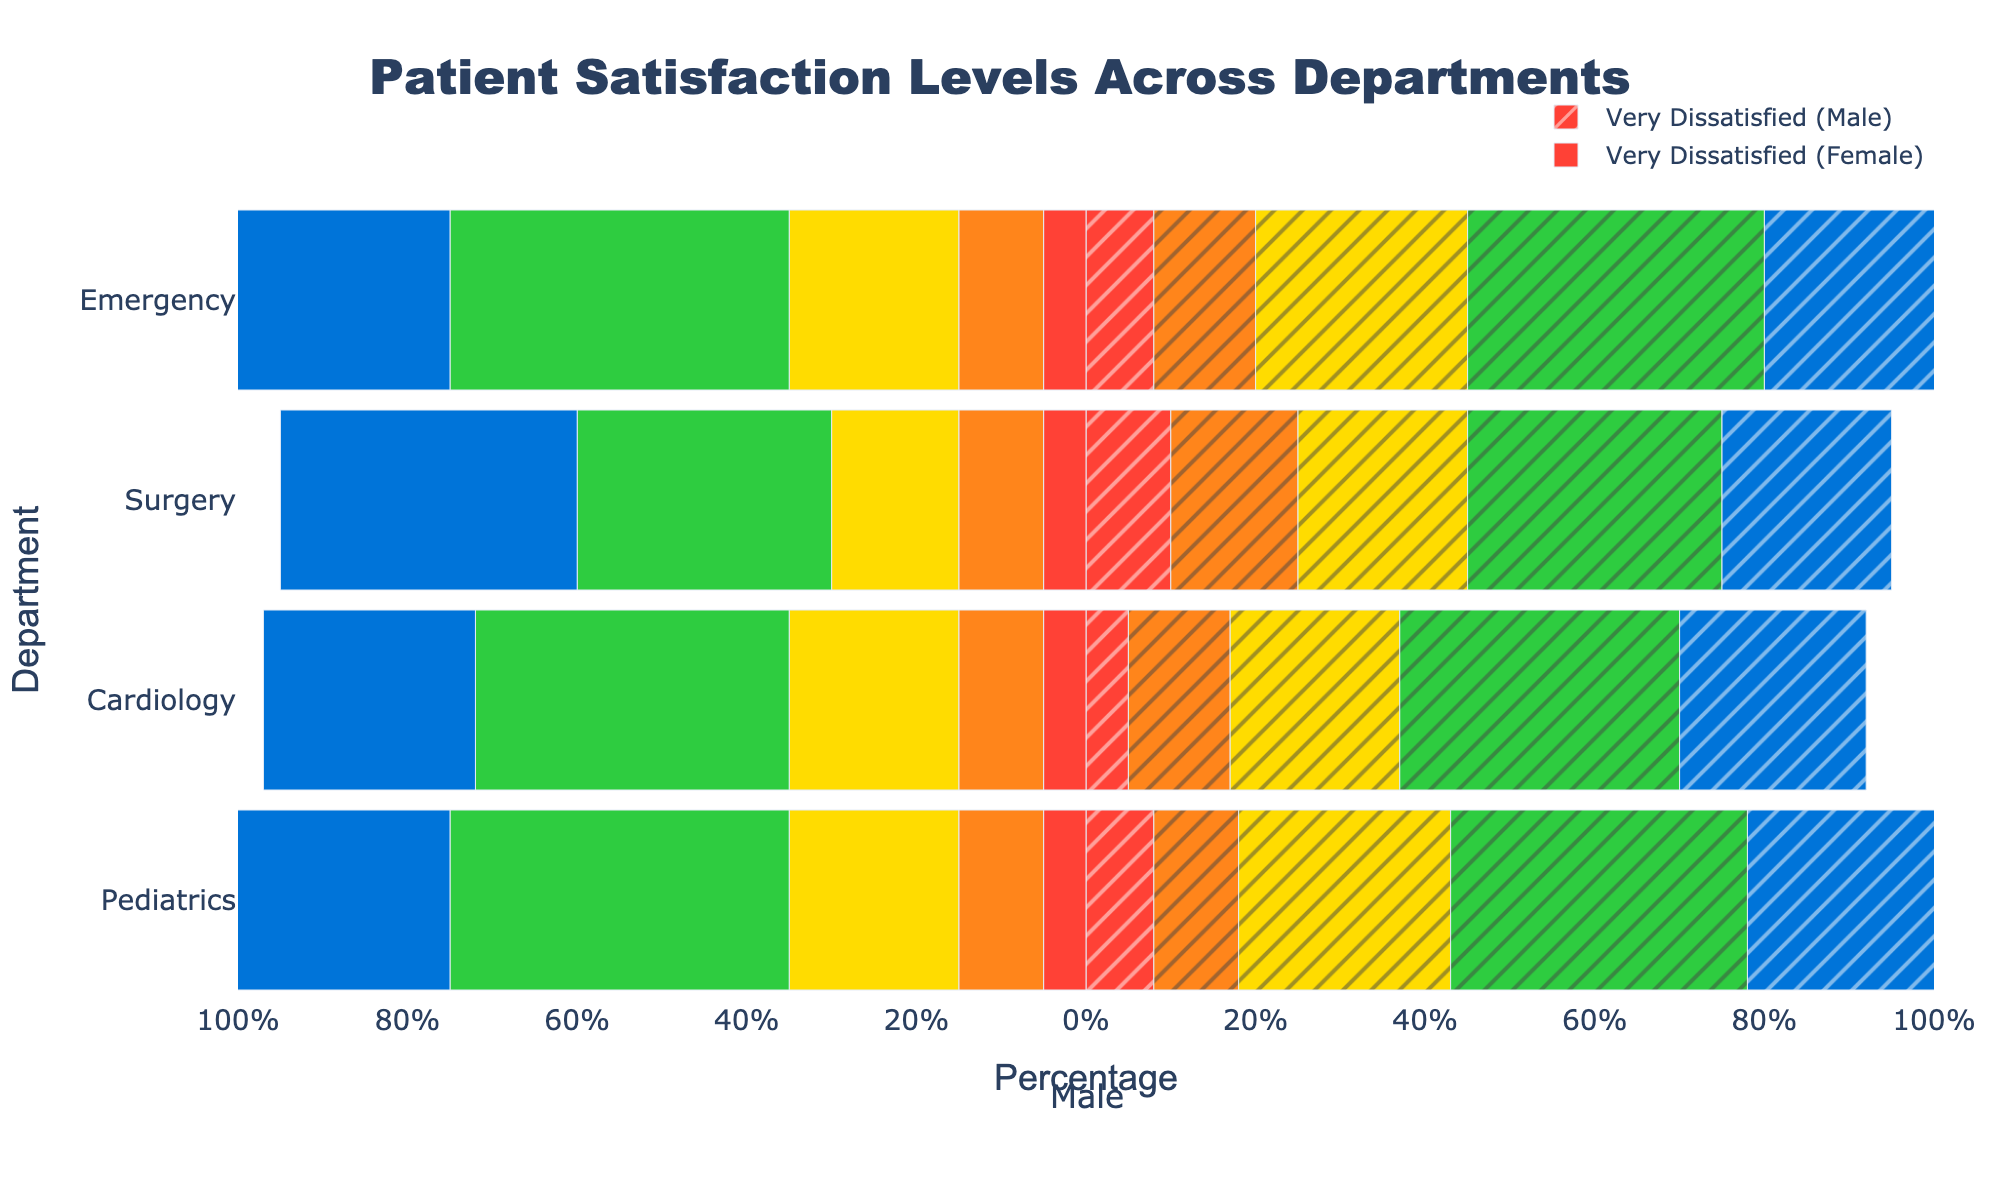What's the percentage of female patients who are 'Very Satisfied' in the Emergency department? Look at the "Very Satisfied (Female)" bar in the Emergency department, it extends to 30 on the positive x-axis.
Answer: 30% Which department has the highest percentage of male patients who are 'Satisfied'? Compare the "Satisfied (Male)" bars across all departments; the Surgery department has the highest bar reaching 35.
Answer: Surgery In the Pediatrics department, what is the difference in 'Neutral' ratings between males and females? The "Neutral (Male)" bar extends to 25 and the "Neutral (Female)" bar extends to -20. The difference is 25 - 20 = 5.
Answer: 5% For the Surgery department, compare the 'Very Dissatisfied' rating percentages between males and females. Which gender has a higher percentage? The "Very Dissatisfied (Male)" bar reaches 5, and the "Very Dissatisfied (Female)" bar also reaches -5. They are equal.
Answer: Equal What department shows the greatest disparity in 'Very Satisfied' ratings between genders? Compare the height of "Very Satisfied (Male)" and "Very Satisfied (Female)" bars for all departments. Pediatrics has the largest difference: males at 20 and females at 35, a 15-point disparity.
Answer: Pediatrics Calculate the total satisfaction (sum of 'Very Satisfied' and 'Satisfied' ratings) for male patients in Cardiology. For males in Cardiology: "Very Satisfied" is 22 and "Satisfied" is 33. Summing these values gives 22 + 33 = 55.
Answer: 55% Which gender tends to have higher satisfaction ratings (sum of 'Very Satisfied' and 'Satisfied') in the Emergency department? For females, "Very Satisfied" and "Satisfied" ratings are 30 and 40, respectively, totaling 70. For males, the ratings are 25 and 35, totaling 60. So, females have higher satisfaction ratings.
Answer: Female In which department do female patients have the lowest percentage of 'Dissatisfied' ratings? Compare the "Dissatisfied (Female)" bars across all departments. Surgery and Cardiology both have the lowest bar at 10.
Answer: Surgery and Cardiology By how much do male patients exceed female patients in 'Dissatisfied' ratings in the Pediatrics department? The "Dissatisfied (Male)" bar is at 15 and the "Dissatisfied (Female)" bar is at -10. The difference is 15 - 10 = 5.
Answer: 5% Which department has the most balanced distribution of ratings for male patients? Observe which department has "Very Dissatisfied", "Dissatisfied", "Neutral", "Satisfied", and "Very Satisfied" bars for males, close to each other. Pediatrics seems most balanced with all ratings present.
Answer: Pediatrics 